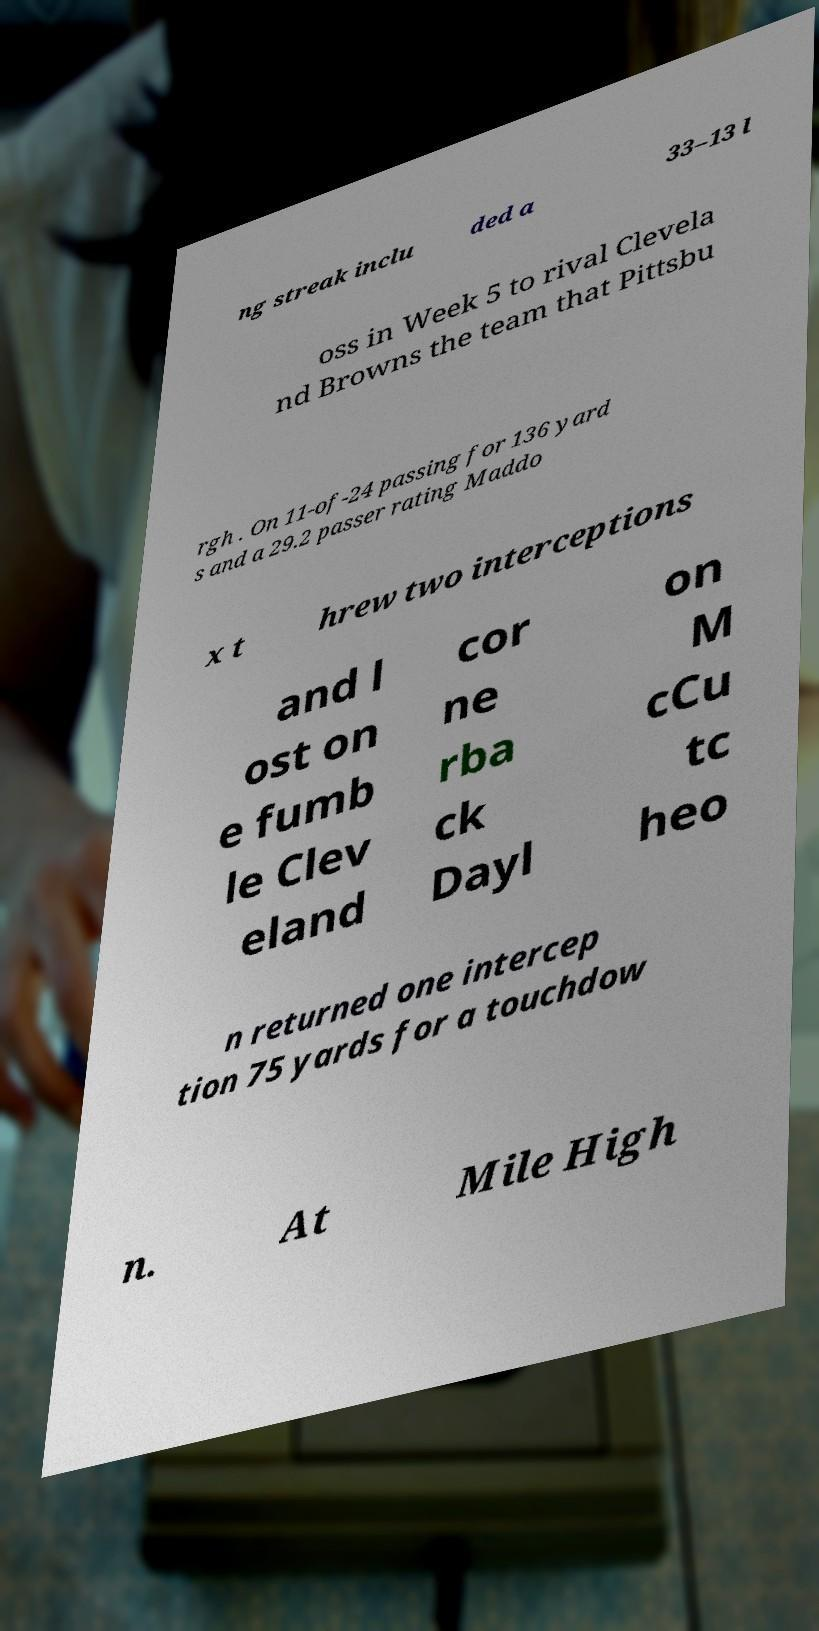Could you assist in decoding the text presented in this image and type it out clearly? ng streak inclu ded a 33–13 l oss in Week 5 to rival Clevela nd Browns the team that Pittsbu rgh . On 11-of-24 passing for 136 yard s and a 29.2 passer rating Maddo x t hrew two interceptions and l ost on e fumb le Clev eland cor ne rba ck Dayl on M cCu tc heo n returned one intercep tion 75 yards for a touchdow n. At Mile High 